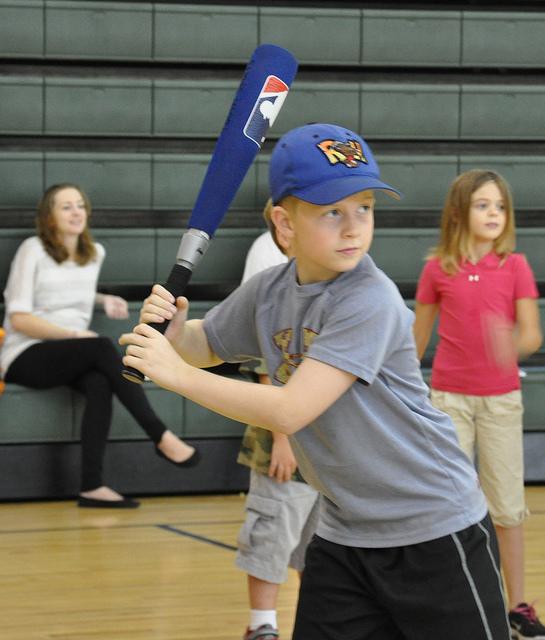Are the bleachers empty?
Write a very short answer. No. What game is this?
Give a very brief answer. Baseball. What sport is being played?
Keep it brief. Baseball. Are these people professional athletes?
Concise answer only. No. What kind of shoes is the woman in the background wearing?
Answer briefly. Flats. What is he holding?
Write a very short answer. Bat. What competition are the men competing in?
Answer briefly. Baseball. What is the child riding?
Keep it brief. Nothing. 